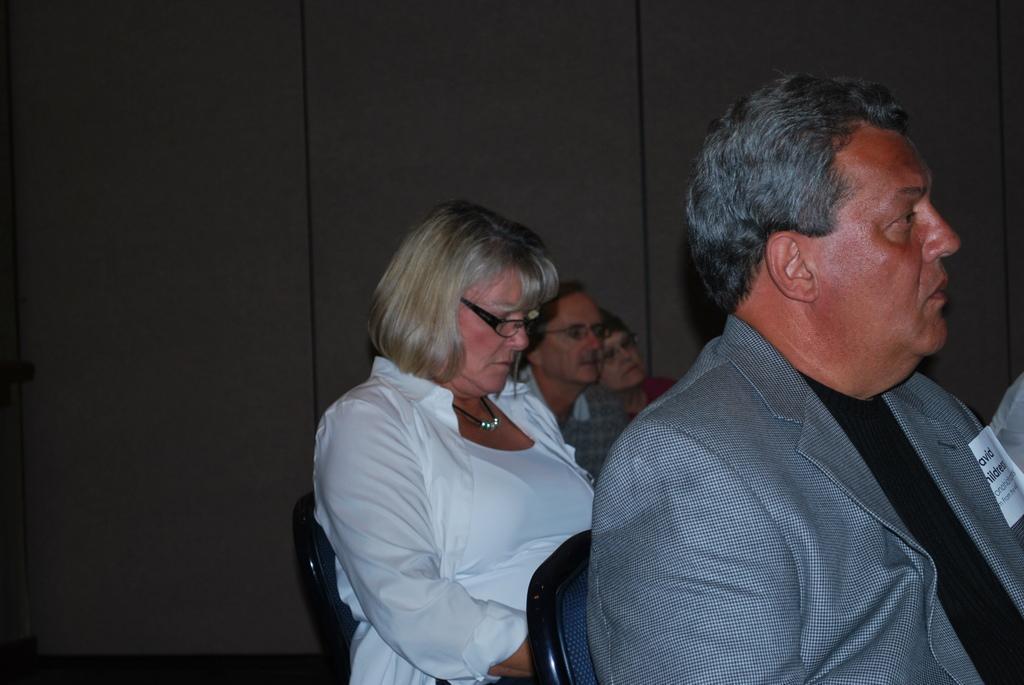Describe this image in one or two sentences. Front this man is sitting on a chair wore suit. Background this persons are also sitting on chairs. This woman wore white jacket and spectacles. 